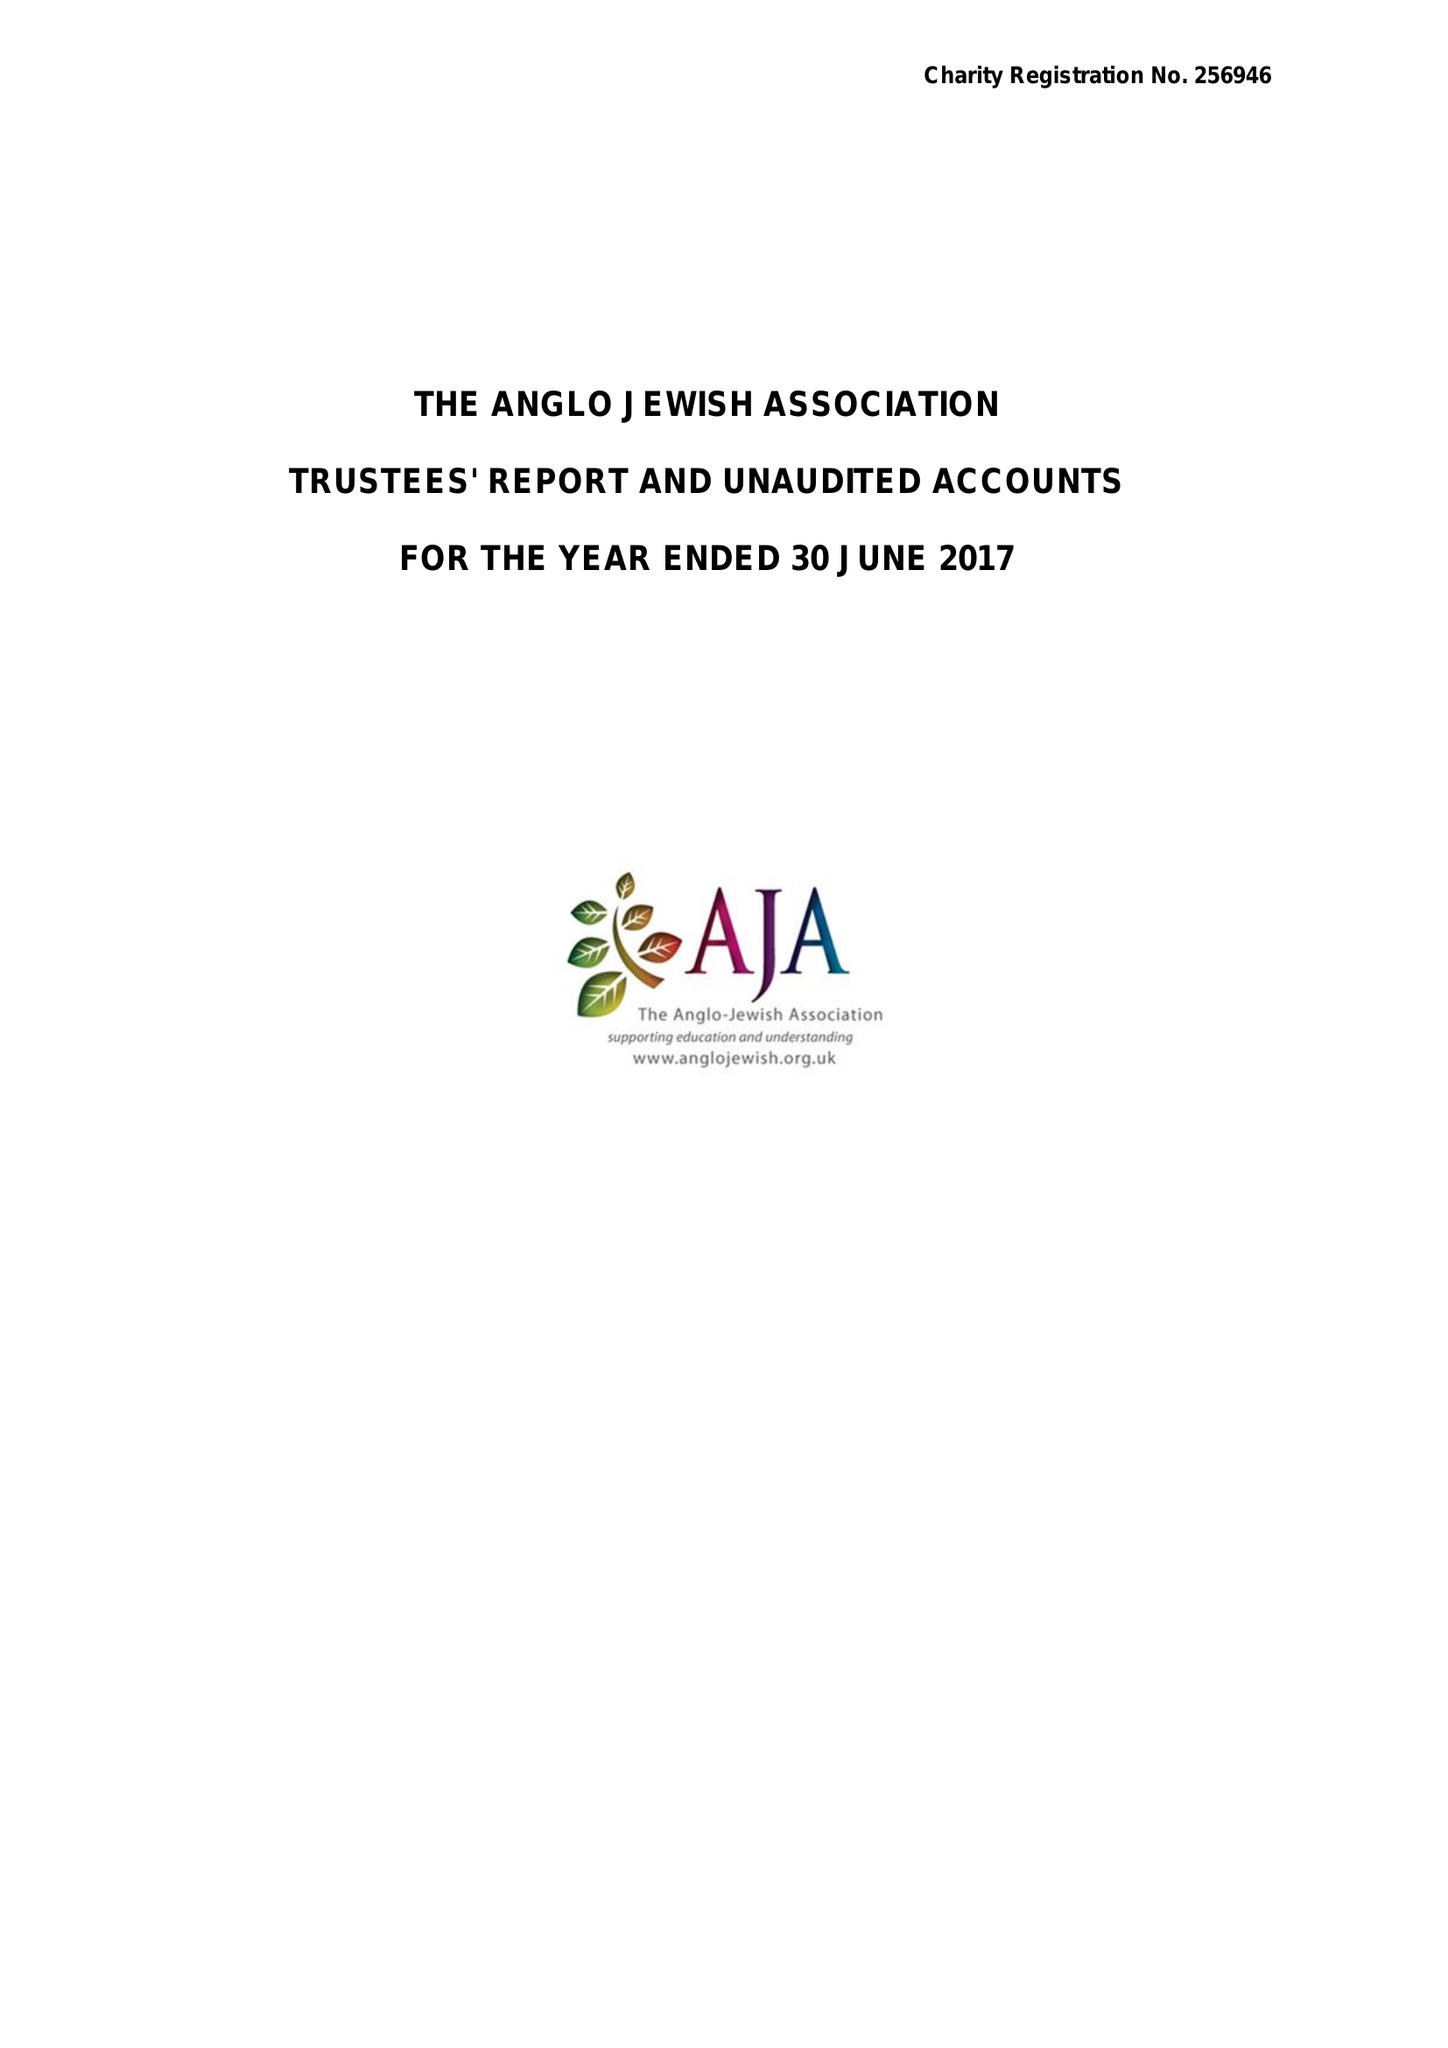What is the value for the address__street_line?
Answer the question using a single word or phrase. 75 MAYGROVE ROAD 